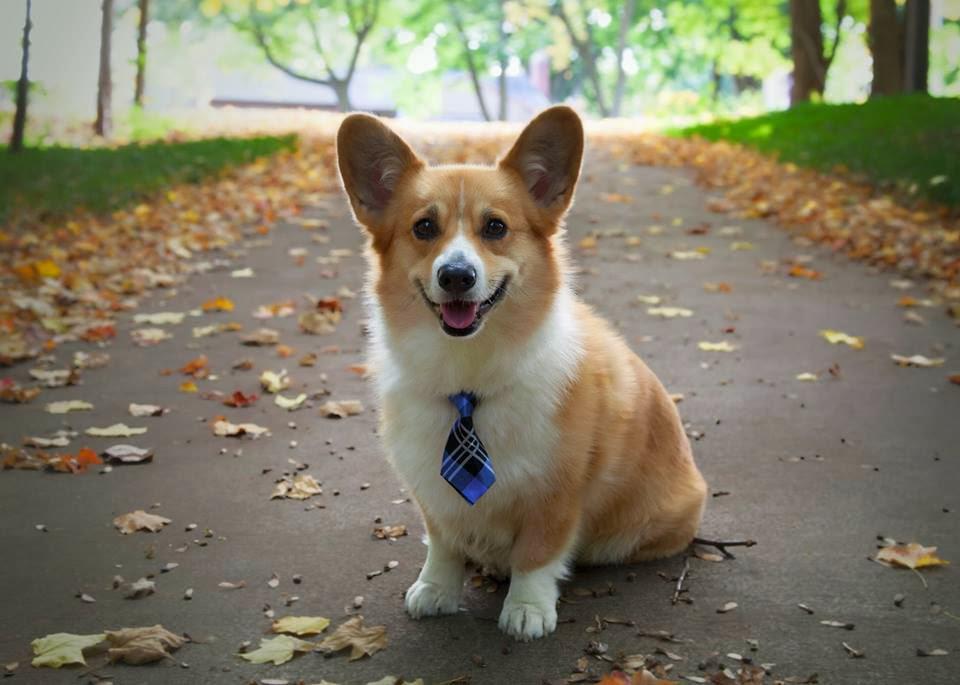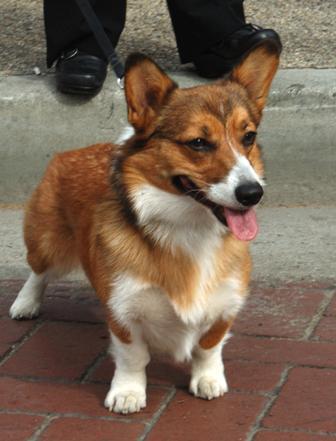The first image is the image on the left, the second image is the image on the right. Evaluate the accuracy of this statement regarding the images: "There are at most four dogs.". Is it true? Answer yes or no. Yes. The first image is the image on the left, the second image is the image on the right. Analyze the images presented: Is the assertion "One imag shows a tri-color corgi dog posed side-by-side with an orange-and-white corgi dog, with their bodies turned forward." valid? Answer yes or no. No. 